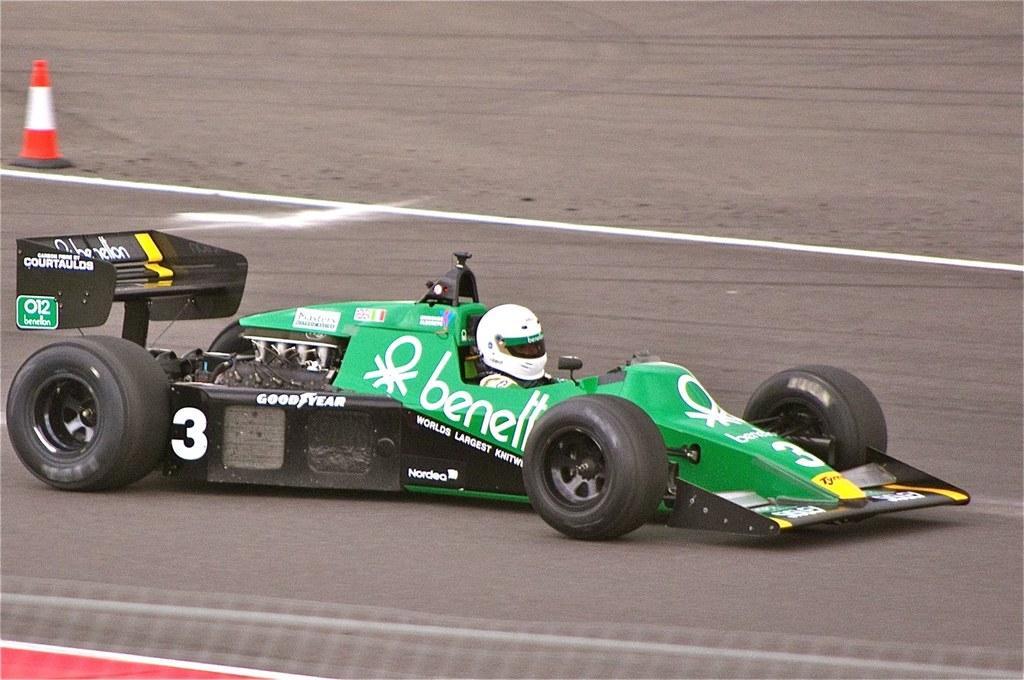Please provide a concise description of this image. This image is taken outdoors. At the bottom of the image there is a road. On the left side of the image there is a safety cone on the road. In the middle of the image there is a Go Kart is moving on the road and a person is sitting in the Go Kart. 